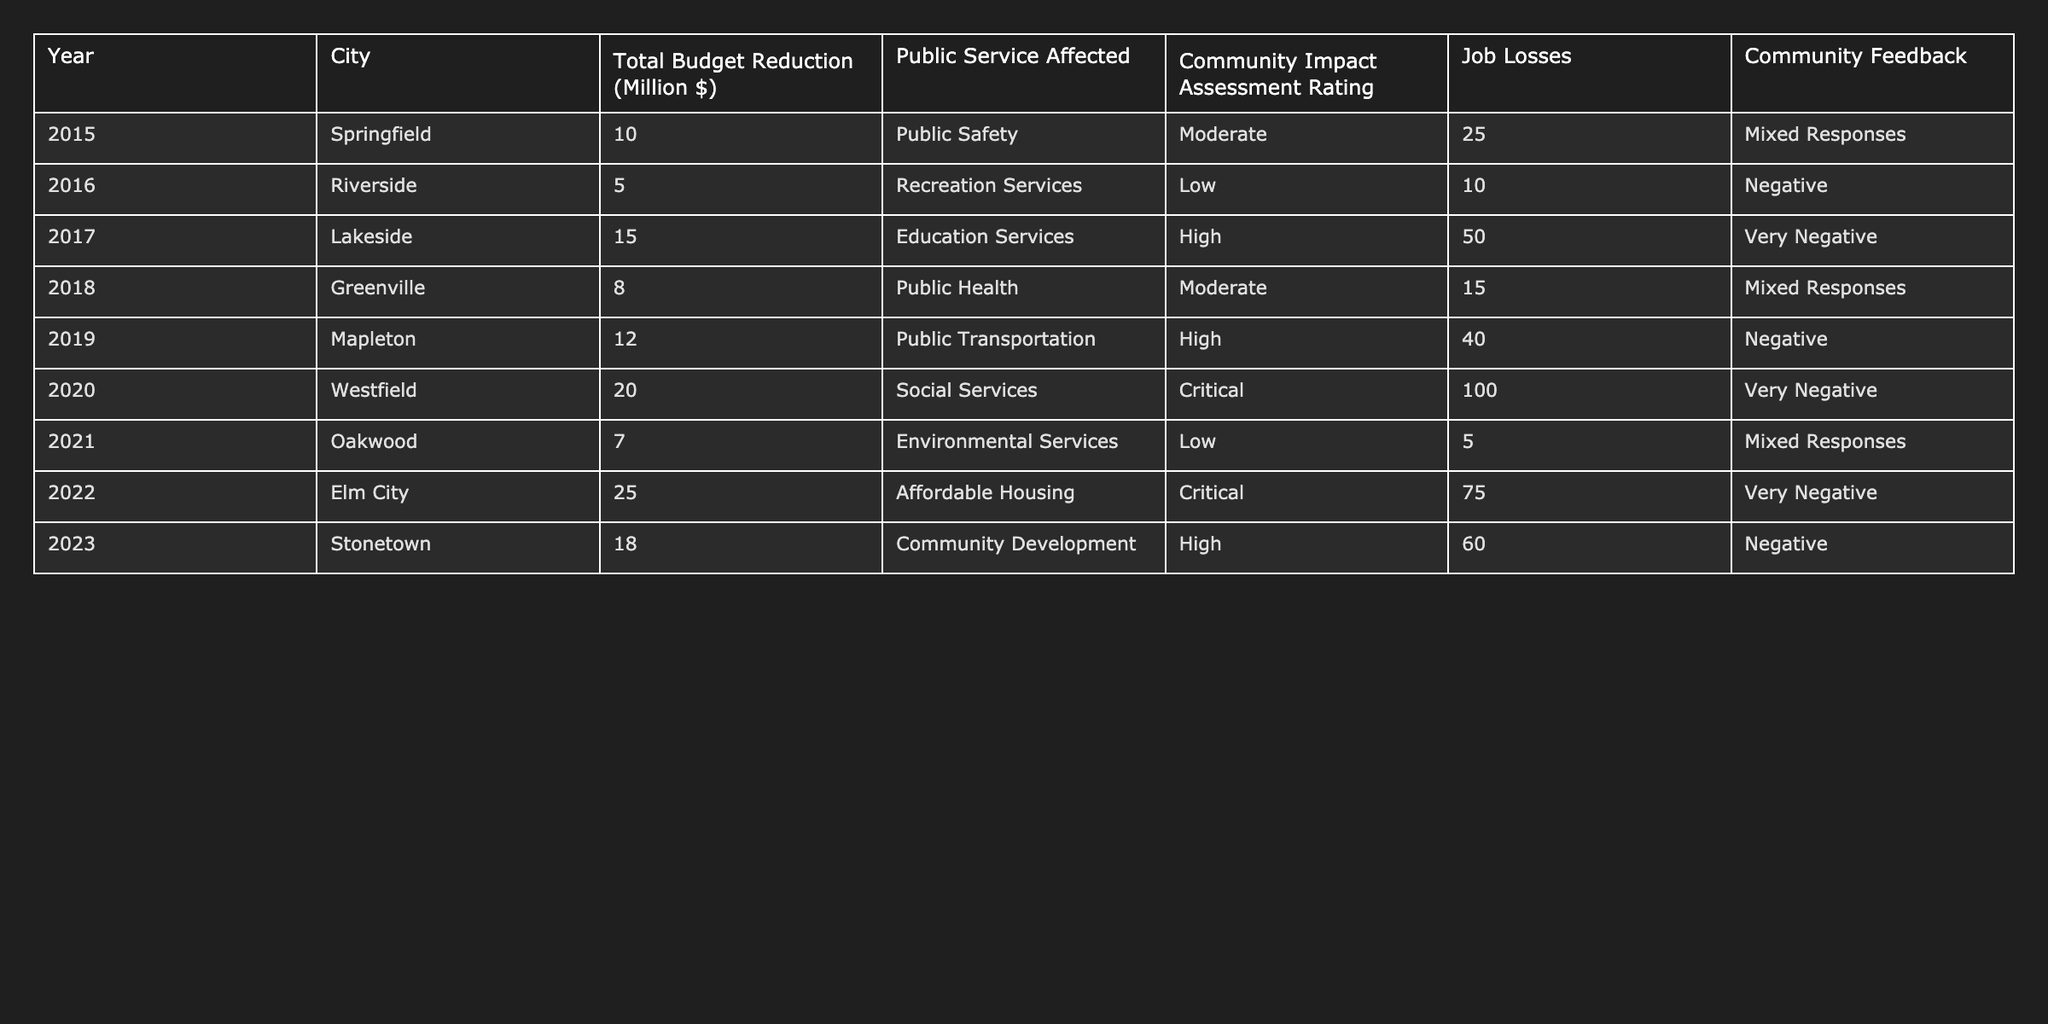What year saw the highest total budget reduction? By reviewing the "Total Budget Reduction (Million $)" column, the year with the highest reduction is 2022 with 25 million dollars.
Answer: 2022 How many job losses were recorded in Stonetown? Looking at the "Job Losses" column for Stonetown, it shows that there were 60 job losses.
Answer: 60 What was the community feedback for the budget reduction in 2017? In the "Community Feedback" column for the year 2017 (Lakeside), the feedback was "Very Negative."
Answer: Very Negative What is the average total budget reduction from 2015 to 2023? First, sum the total budget reductions: 10 + 5 + 15 + 8 + 12 + 20 + 7 + 25 + 18 = 120 million. Then, divide by the number of years, which is 9: 120 / 9 = 13.33 million.
Answer: 13.33 million Did any city experience a critical community impact assessment rating after budget reductions? Yes, both Westfield (2020) and Elm City (2022) had a "Critical" rating in the "Community Impact Assessment Rating" column.
Answer: Yes What was the percentage of job losses associated with the lowest budget reduction? The lowest budget reduction is 5 million in Riverside with 10 job losses. The calculation is (10 job losses / 5 million) * 100 = 200 job losses per million.
Answer: 200 job losses per million Which public service had the most job losses? By examining the "Job Losses" column, Social Services in Westfield experienced the most job losses at 100.
Answer: Social Services How does the community impact assessment rating relate to the level of budget reduction? A comparison reveals that higher budget reductions typically resulted in higher impact ratings: for example, Elm City (25 million) had a "Critical" rating, while Riverside (5 million) had a "Low" rating.
Answer: Generally, higher reductions lead to worse ratings How many cities had “Mixed Responses” in community feedback? Reviewing the "Community Feedback" column, Springfield, Greenville, and Oakwood each had "Mixed Responses," totaling three cities.
Answer: 3 cities What is the difference in job losses between 2020 and 2019? The job losses in 2020 (100) minus those in 2019 (40) equals a difference of 60 job losses.
Answer: 60 job losses 